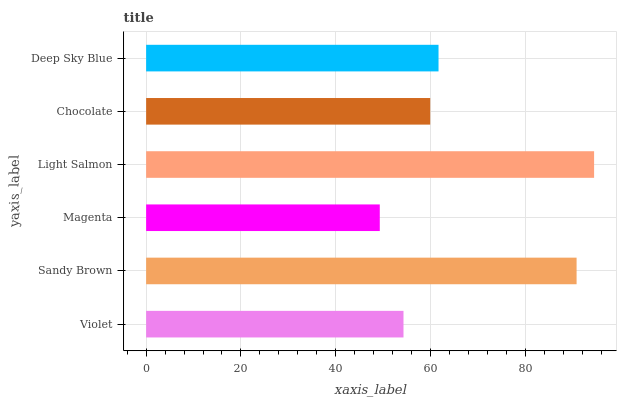Is Magenta the minimum?
Answer yes or no. Yes. Is Light Salmon the maximum?
Answer yes or no. Yes. Is Sandy Brown the minimum?
Answer yes or no. No. Is Sandy Brown the maximum?
Answer yes or no. No. Is Sandy Brown greater than Violet?
Answer yes or no. Yes. Is Violet less than Sandy Brown?
Answer yes or no. Yes. Is Violet greater than Sandy Brown?
Answer yes or no. No. Is Sandy Brown less than Violet?
Answer yes or no. No. Is Deep Sky Blue the high median?
Answer yes or no. Yes. Is Chocolate the low median?
Answer yes or no. Yes. Is Light Salmon the high median?
Answer yes or no. No. Is Light Salmon the low median?
Answer yes or no. No. 